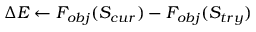<formula> <loc_0><loc_0><loc_500><loc_500>\Delta E \gets F _ { o b j } ( S _ { c u r } ) - F _ { o b j } ( S _ { t r y } )</formula> 